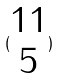Convert formula to latex. <formula><loc_0><loc_0><loc_500><loc_500>( \begin{matrix} 1 1 \\ 5 \end{matrix} )</formula> 